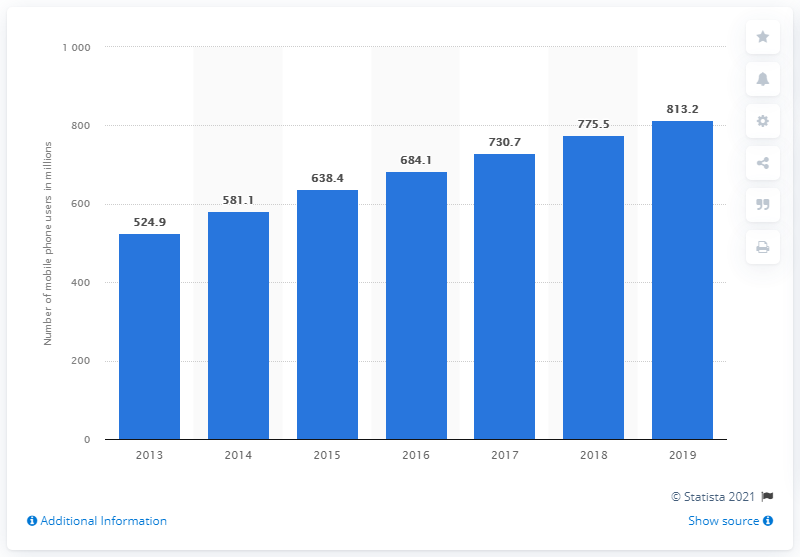Indicate a few pertinent items in this graphic. In 2014, there were 581.1 million mobile phone users in India. 